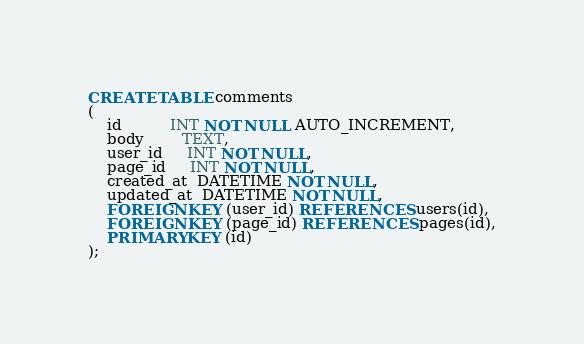Convert code to text. <code><loc_0><loc_0><loc_500><loc_500><_SQL_>CREATE TABLE comments
(
    id          INT NOT NULL AUTO_INCREMENT,
    body        TEXT,
    user_id     INT NOT NULL,
    page_id     INT NOT NULL,
    created_at  DATETIME NOT NULL,
    updated_at  DATETIME NOT NULL,
    FOREIGN KEY (user_id) REFERENCES users(id),
    FOREIGN KEY (page_id) REFERENCES pages(id),
    PRIMARY KEY (id)
);</code> 